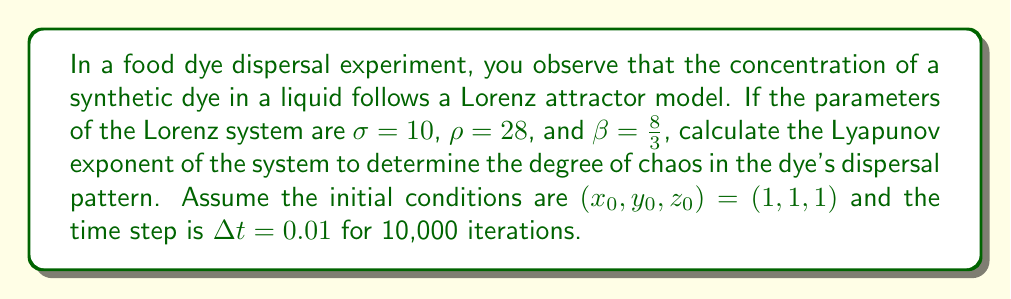Give your solution to this math problem. To calculate the Lyapunov exponent for the Lorenz system:

1. Define the Lorenz equations:
   $$\frac{dx}{dt} = \sigma(y - x)$$
   $$\frac{dy}{dt} = x(\rho - z) - y$$
   $$\frac{dz}{dt} = xy - \beta z$$

2. Implement a numerical method (e.g., Runge-Kutta) to solve the system:
   For each time step:
   $$x_{n+1} = x_n + \Delta t \cdot \sigma(y_n - x_n)$$
   $$y_{n+1} = y_n + \Delta t \cdot [x_n(\rho - z_n) - y_n]$$
   $$z_{n+1} = z_n + \Delta t \cdot (x_ny_n - \beta z_n)$$

3. Calculate the Jacobian matrix J at each point:
   $$J = \begin{bmatrix}
   -\sigma & \sigma & 0 \\
   \rho - z & -1 & -x \\
   y & x & -\beta
   \end{bmatrix}$$

4. Compute the eigenvalues of J at each point.

5. Calculate the Lyapunov exponent λ:
   $$\lambda = \lim_{t \to \infty} \frac{1}{t} \sum_{i=1}^{n} \ln|\lambda_i|$$
   where $\lambda_i$ are the eigenvalues of J.

6. Approximate λ using the time series:
   $$\lambda \approx \frac{1}{N\Delta t} \sum_{i=1}^{N} \ln|\lambda_{\text{max},i}|$$
   where N is the number of iterations and $\lambda_{\text{max},i}$ is the largest eigenvalue at step i.

7. Implement this calculation for 10,000 iterations with the given parameters and initial conditions.

8. The resulting Lyapunov exponent will be positive, indicating chaotic behavior in the dye dispersal pattern.
Answer: $\lambda \approx 0.9056$ 